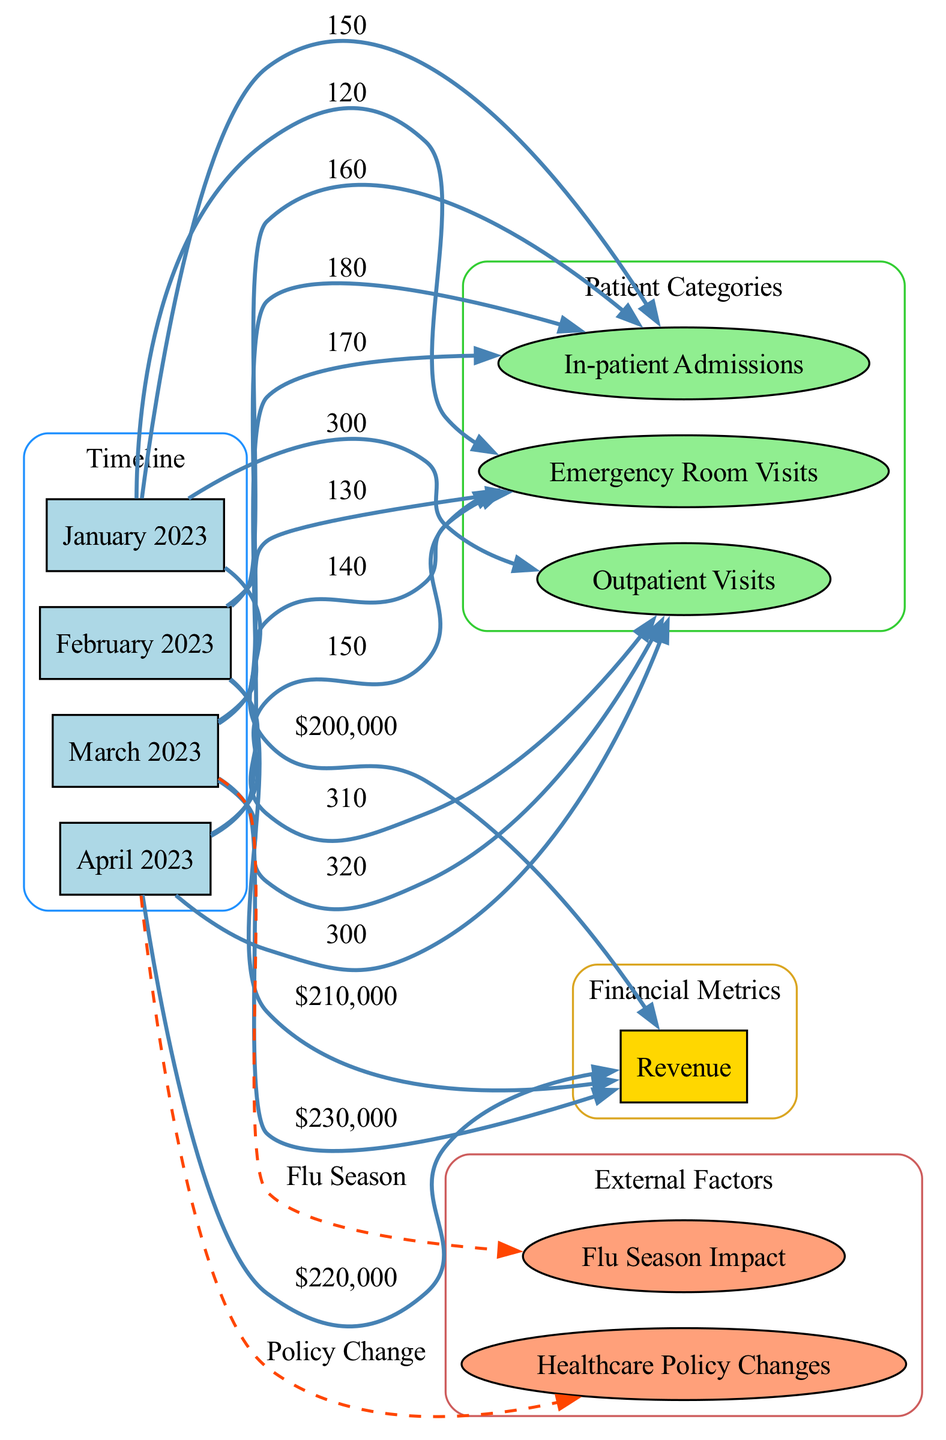What was the revenue generated in March 2023? In the diagram, we look for the node representing March 2023, which connects to the revenue node. The edge between March 2023 and revenue indicates the amount, which is labeled as $230,000.
Answer: $230,000 How many emergency room visits were recorded in February 2023? Analyzing the node for February 2023, we find an edge connecting to the emergency room visits node. This edge displays the value as 130.
Answer: 130 Which month experienced the highest in-patient admissions? To determine this, we observe the in-patient admissions for each month. January had 150, February had 160, March had 180, and April had 170. March shows the highest value at 180.
Answer: March How many total patient admissions (in-patients, outpatients, emergency room visits) were there in April 2023? For April, we note the values: in-patient admissions was 170, outpatient visits was 300, and emergency room visits was 150. Adding these values gives 170 + 300 + 150 = 620.
Answer: 620 What external factor influenced March 2023 in the diagram? We check the influence relationships for March. The node for March is connected to the external factor labeled "Flu Season," indicating it had an influence on that month.
Answer: Flu Season Which patient category had the most visits in January 2023? By examining the edge connections for January 2023, we see in-patient admissions (150), outpatient visits (300), and emergency room visits (120). Outpatient visits has the highest number at 300.
Answer: Outpatient Visits How many nodes represent financial metrics in the diagram? The diagram includes a node for revenue as the only financial metric. Thus, we count the nodes categorized as financial metric, which totals to 1.
Answer: 1 What change occurred in revenue from January 2023 to March 2023? For January, the revenue was $200,000, and for March, it was $230,000. Calculating the difference: $230,000 - $200,000 equals $30,000 increase.
Answer: $30,000 increase Which month had an influence from healthcare policy changes? The diagram shows an edge linking April to an external factor labeled "Policy Change." Thus, April is identified as having this influence.
Answer: April 